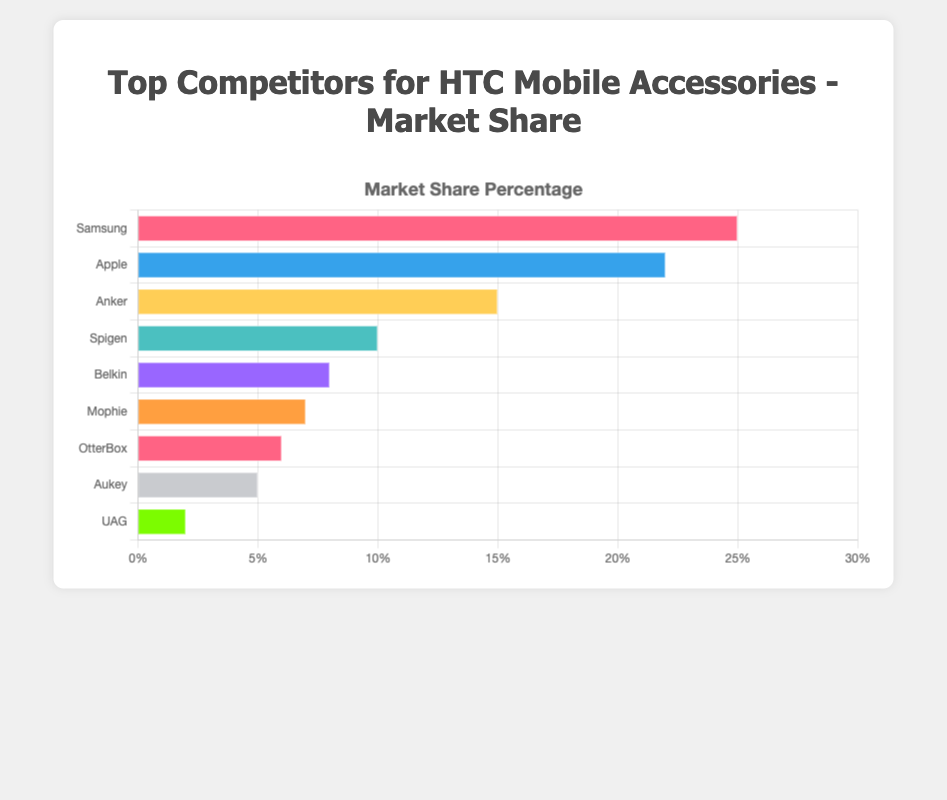What is the company with the highest market share in HTC mobile accessories? Samsung has the highest market share percentage at 25%.
Answer: Samsung How much more market share does Samsung have compared to OtterBox? Samsung has a market share of 25%, and OtterBox has 6%, so the difference is 25% - 6% = 19%.
Answer: 19% Which companies have a market share of less than 10%? The companies with less than 10% market share are Belkin (8%), Mophie (7%), OtterBox (6%), Aukey (5%), and UAG (2%).
Answer: Belkin, Mophie, OtterBox, Aukey, UAG What is the total market share of Apple and Anker combined? Apple has a market share of 22%, and Anker has 15%. The combined market share is 22% + 15% = 37%.
Answer: 37% Which company has the smallest market share, and what is its percentage? UAG has the smallest market share at 2%.
Answer: UAG, 2% What is the combined market share of the top three competitors? The top three competitors are Samsung (25%), Apple (22%), and Anker (15%). Their combined market share is 25% + 22% + 15% = 62%.
Answer: 62% How does Belkin’s market share compare to that of Mophie? Belkin has an 8% market share whereas Mophie has 7%. Belkin has 1% more market share than Mophie.
Answer: Belkin has 1% more If HTC accessories aim to capture a higher market share than Aukey, by how much do they need to increase their market share? Aukey's market share is 5%. To surpass Aukey, HTC needs to capture more than 5%. If HTC currently has 0%, they need to increase by more than 5%.
Answer: More than 5% What is the average market share of the companies with more than 10% market share? The companies with more than 10% market share are Samsung (25%), Apple (22%), and Anker (15%). The average market share is (25% + 22% + 15%) / 3 ≈ 20.67%.
Answer: 20.67% By how much does the sum of the market shares of Spigen, Belkin, and Mophie exceed OtterBox’s market share? The market shares are Spigen (10%), Belkin (8%), Mophie (7%), and OtterBox (6%). The sum for Spigen, Belkin, and Mophie is 10% + 8% + 7% = 25%. The difference is 25% - 6% = 19%.
Answer: 19% 